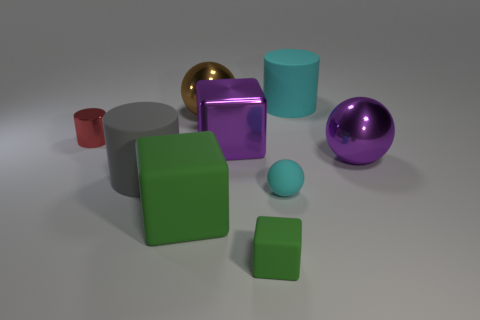What number of big matte objects are right of the cylinder that is behind the tiny metallic thing?
Make the answer very short. 0. There is a big purple object that is on the left side of the matte block in front of the green matte object that is left of the brown shiny object; what shape is it?
Your response must be concise. Cube. There is a metal object that is the same color as the big metallic cube; what is its size?
Offer a very short reply. Large. How many objects are large green rubber blocks or cylinders?
Offer a terse response. 4. There is another cube that is the same size as the purple block; what color is it?
Your response must be concise. Green. Do the big brown object and the matte thing behind the gray cylinder have the same shape?
Provide a succinct answer. No. What number of things are shiny objects in front of the tiny cylinder or big shiny things that are behind the small cylinder?
Provide a succinct answer. 3. The rubber thing that is the same color as the small rubber ball is what shape?
Provide a short and direct response. Cylinder. What is the shape of the cyan object behind the large gray matte cylinder?
Your answer should be compact. Cylinder. Does the matte thing that is behind the tiny shiny thing have the same shape as the small metal thing?
Your answer should be very brief. Yes. 